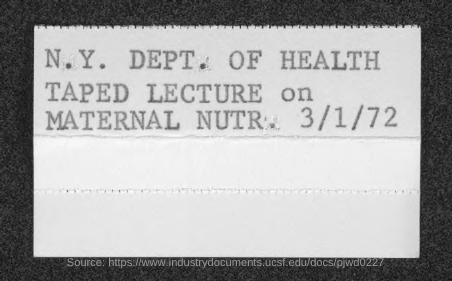Draw attention to some important aspects in this diagram. The date mentioned is March 1, 1972. 